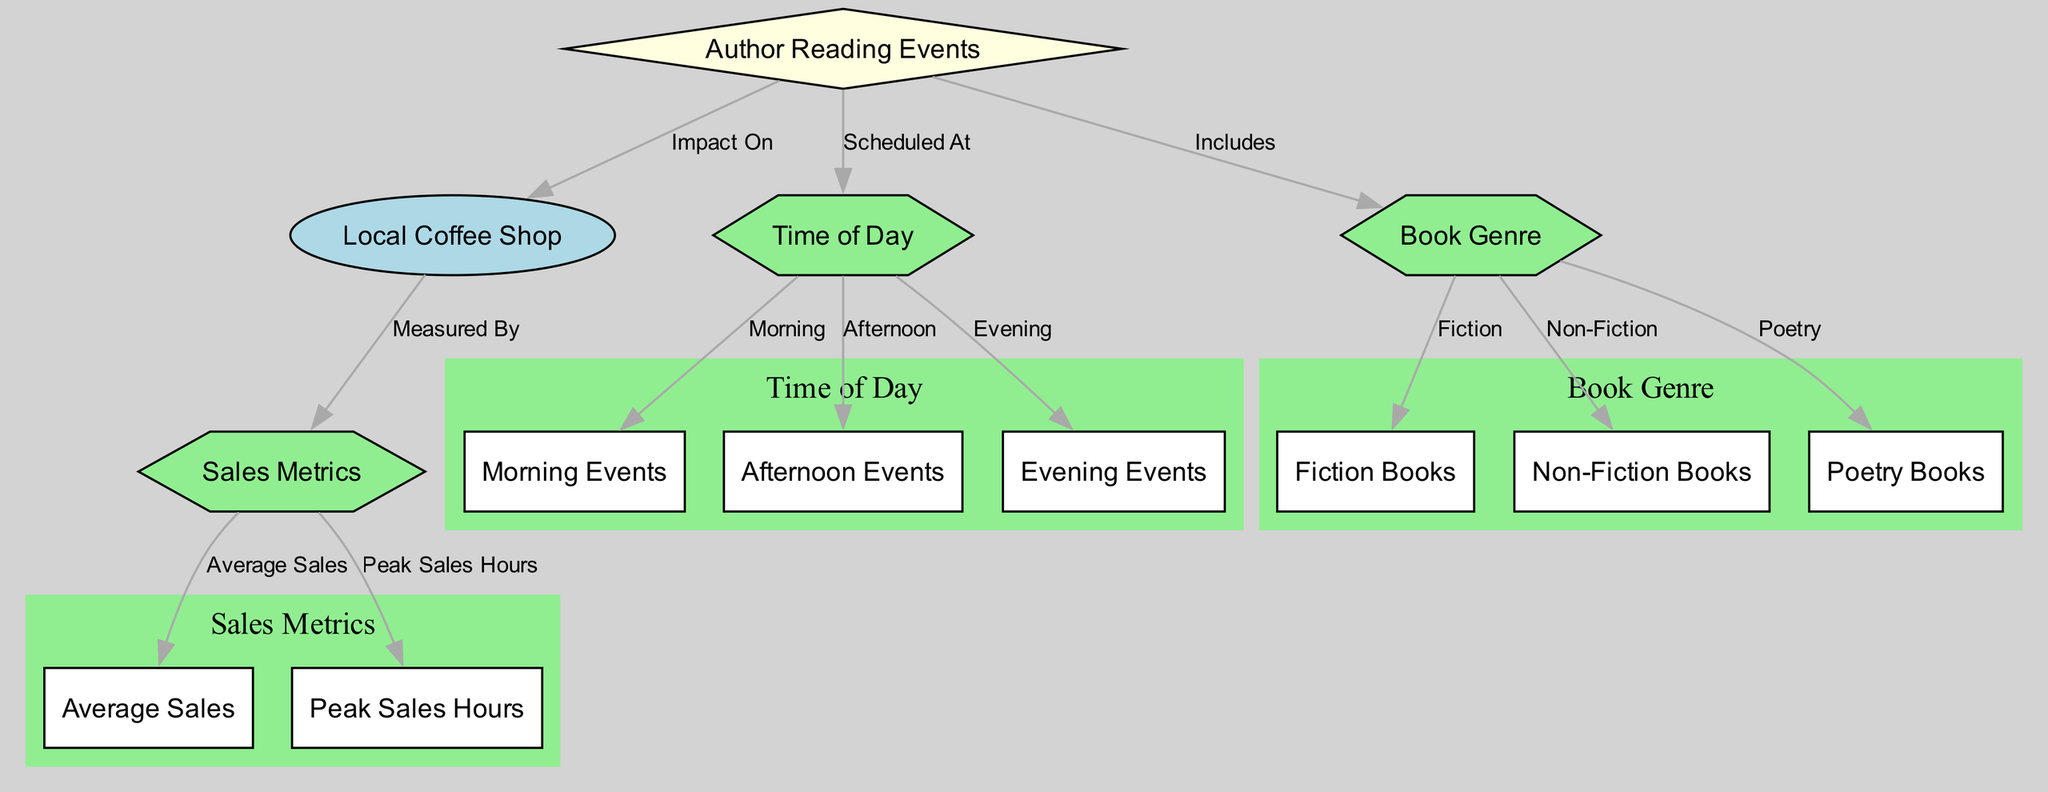What is the central focus of the diagram? The diagram primarily focuses on the relationship between author reading events and the local coffee shop's sales metrics. It visually connects how these events impact sales.
Answer: Impact of Author Readings on Local Coffee Shop Sales How many types of book genres are included in the diagram? The diagram lists three distinct book genres: Fiction, Non-Fiction, and Poetry. Therefore, the total number is three.
Answer: Three Which sales metric specifically measures the highest sales during events? The peak sales hours metric identifies the time period during events when sales are highest, discussed in relation to actions taken or events held.
Answer: Peak Sales Hours What time of day is likely the most advantageous for hosting author readings? Given the nodes in the diagram, evening events imply a potentially higher engagement, but the final validation comes from observing sales metrics collected at various times.
Answer: Evening Events Which type of events directly influences the local coffee shop? The diagram shows a direct edge from author reading events to the coffee shop, indicating that these events impact the coffee shop positively.
Answer: Author Reading Events How many total nodes are present in the diagram? By counting each unique entity represented, one can conclude that there are a total of twelve nodes present in the diagram.
Answer: Twelve What is the relationship between author reading events and time of day? The relationship is depicted as 'scheduled at', indicating that the timing of author readings affects their occurrence and relation to sales.
Answer: Scheduled At Which genre is specifically identified as a subcategory of book genre? The subcategories listed evenly under book genre include fiction books, non-fiction books, and poetry books, with fiction books being specifically asked here.
Answer: Fiction Books How does the diagram categorize the sales metrics? Sales metrics are specifically categorized into average sales and peak sales hours, illustrating how these metrics are organized for understanding sales performance.
Answer: Average Sales, Peak Sales Hours 